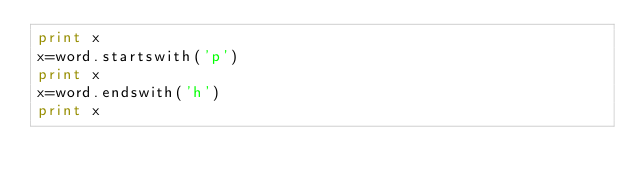<code> <loc_0><loc_0><loc_500><loc_500><_Python_>print x
x=word.startswith('p')
print x
x=word.endswith('h')
print x
</code> 